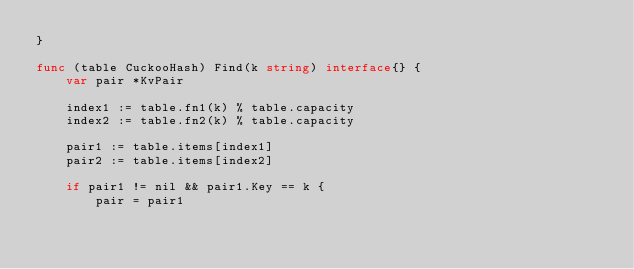<code> <loc_0><loc_0><loc_500><loc_500><_Go_>}

func (table CuckooHash) Find(k string) interface{} {
	var pair *KvPair

	index1 := table.fn1(k) % table.capacity
	index2 := table.fn2(k) % table.capacity

	pair1 := table.items[index1]
	pair2 := table.items[index2]

	if pair1 != nil && pair1.Key == k {
		pair = pair1</code> 